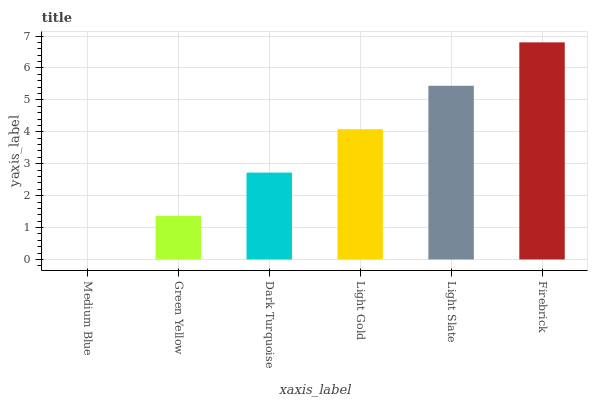Is Medium Blue the minimum?
Answer yes or no. Yes. Is Firebrick the maximum?
Answer yes or no. Yes. Is Green Yellow the minimum?
Answer yes or no. No. Is Green Yellow the maximum?
Answer yes or no. No. Is Green Yellow greater than Medium Blue?
Answer yes or no. Yes. Is Medium Blue less than Green Yellow?
Answer yes or no. Yes. Is Medium Blue greater than Green Yellow?
Answer yes or no. No. Is Green Yellow less than Medium Blue?
Answer yes or no. No. Is Light Gold the high median?
Answer yes or no. Yes. Is Dark Turquoise the low median?
Answer yes or no. Yes. Is Medium Blue the high median?
Answer yes or no. No. Is Light Gold the low median?
Answer yes or no. No. 